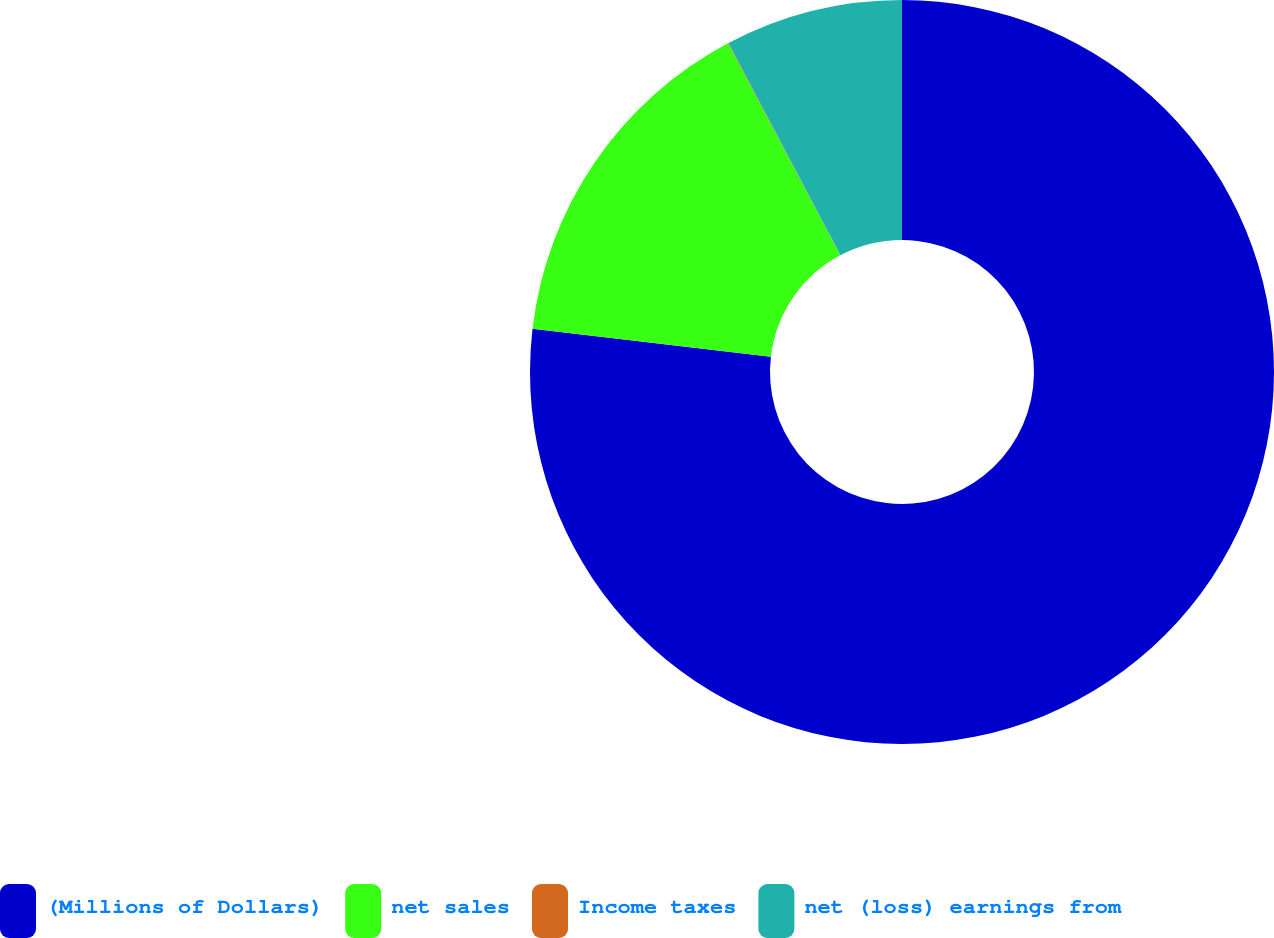Convert chart. <chart><loc_0><loc_0><loc_500><loc_500><pie_chart><fcel>(Millions of Dollars)<fcel>net sales<fcel>Income taxes<fcel>net (loss) earnings from<nl><fcel>76.85%<fcel>15.4%<fcel>0.03%<fcel>7.72%<nl></chart> 